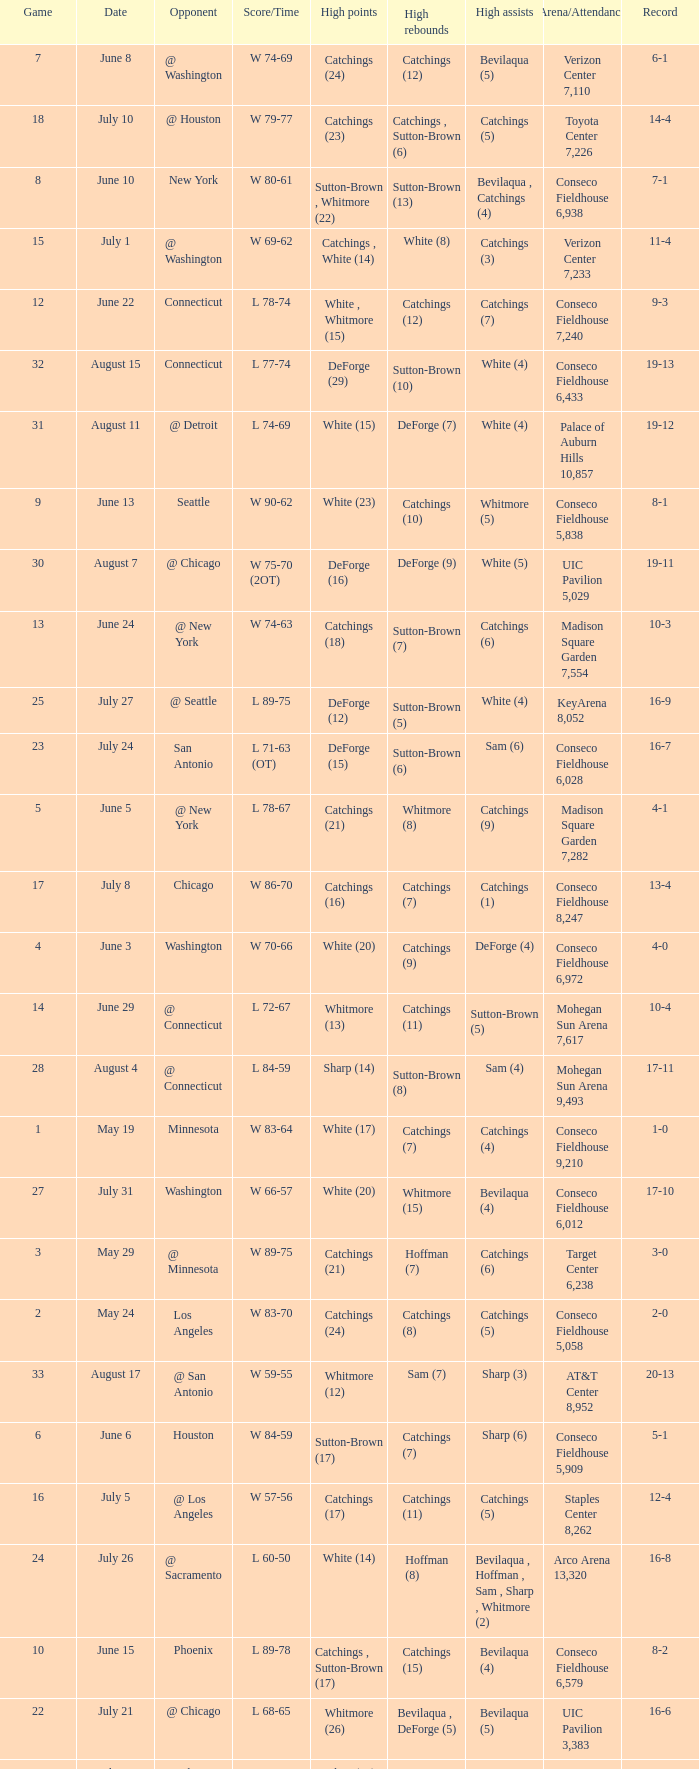Name the date where score time is w 74-63 June 24. 